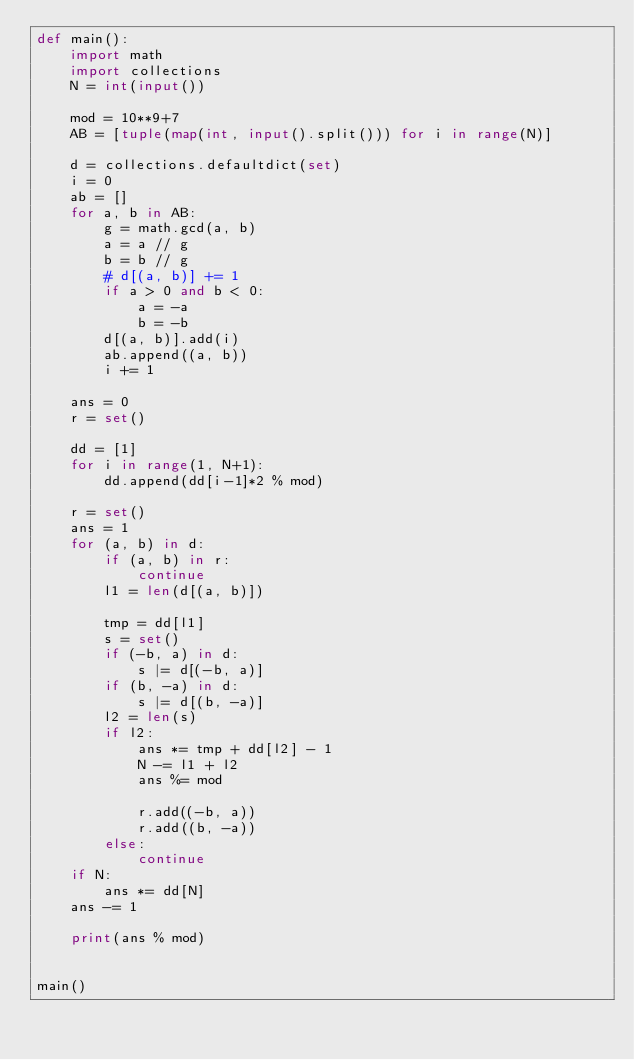<code> <loc_0><loc_0><loc_500><loc_500><_Python_>def main():
    import math
    import collections
    N = int(input())

    mod = 10**9+7
    AB = [tuple(map(int, input().split())) for i in range(N)]

    d = collections.defaultdict(set)
    i = 0
    ab = []
    for a, b in AB:
        g = math.gcd(a, b)
        a = a // g
        b = b // g
        # d[(a, b)] += 1
        if a > 0 and b < 0:
            a = -a
            b = -b
        d[(a, b)].add(i)
        ab.append((a, b))
        i += 1

    ans = 0
    r = set()

    dd = [1]
    for i in range(1, N+1):
        dd.append(dd[i-1]*2 % mod)

    r = set()
    ans = 1
    for (a, b) in d:
        if (a, b) in r:
            continue
        l1 = len(d[(a, b)])

        tmp = dd[l1]
        s = set()
        if (-b, a) in d:
            s |= d[(-b, a)]
        if (b, -a) in d:
            s |= d[(b, -a)]
        l2 = len(s)
        if l2:
            ans *= tmp + dd[l2] - 1
            N -= l1 + l2
            ans %= mod

            r.add((-b, a))
            r.add((b, -a))
        else:
            continue
    if N:
        ans *= dd[N]
    ans -= 1

    print(ans % mod)


main()
</code> 